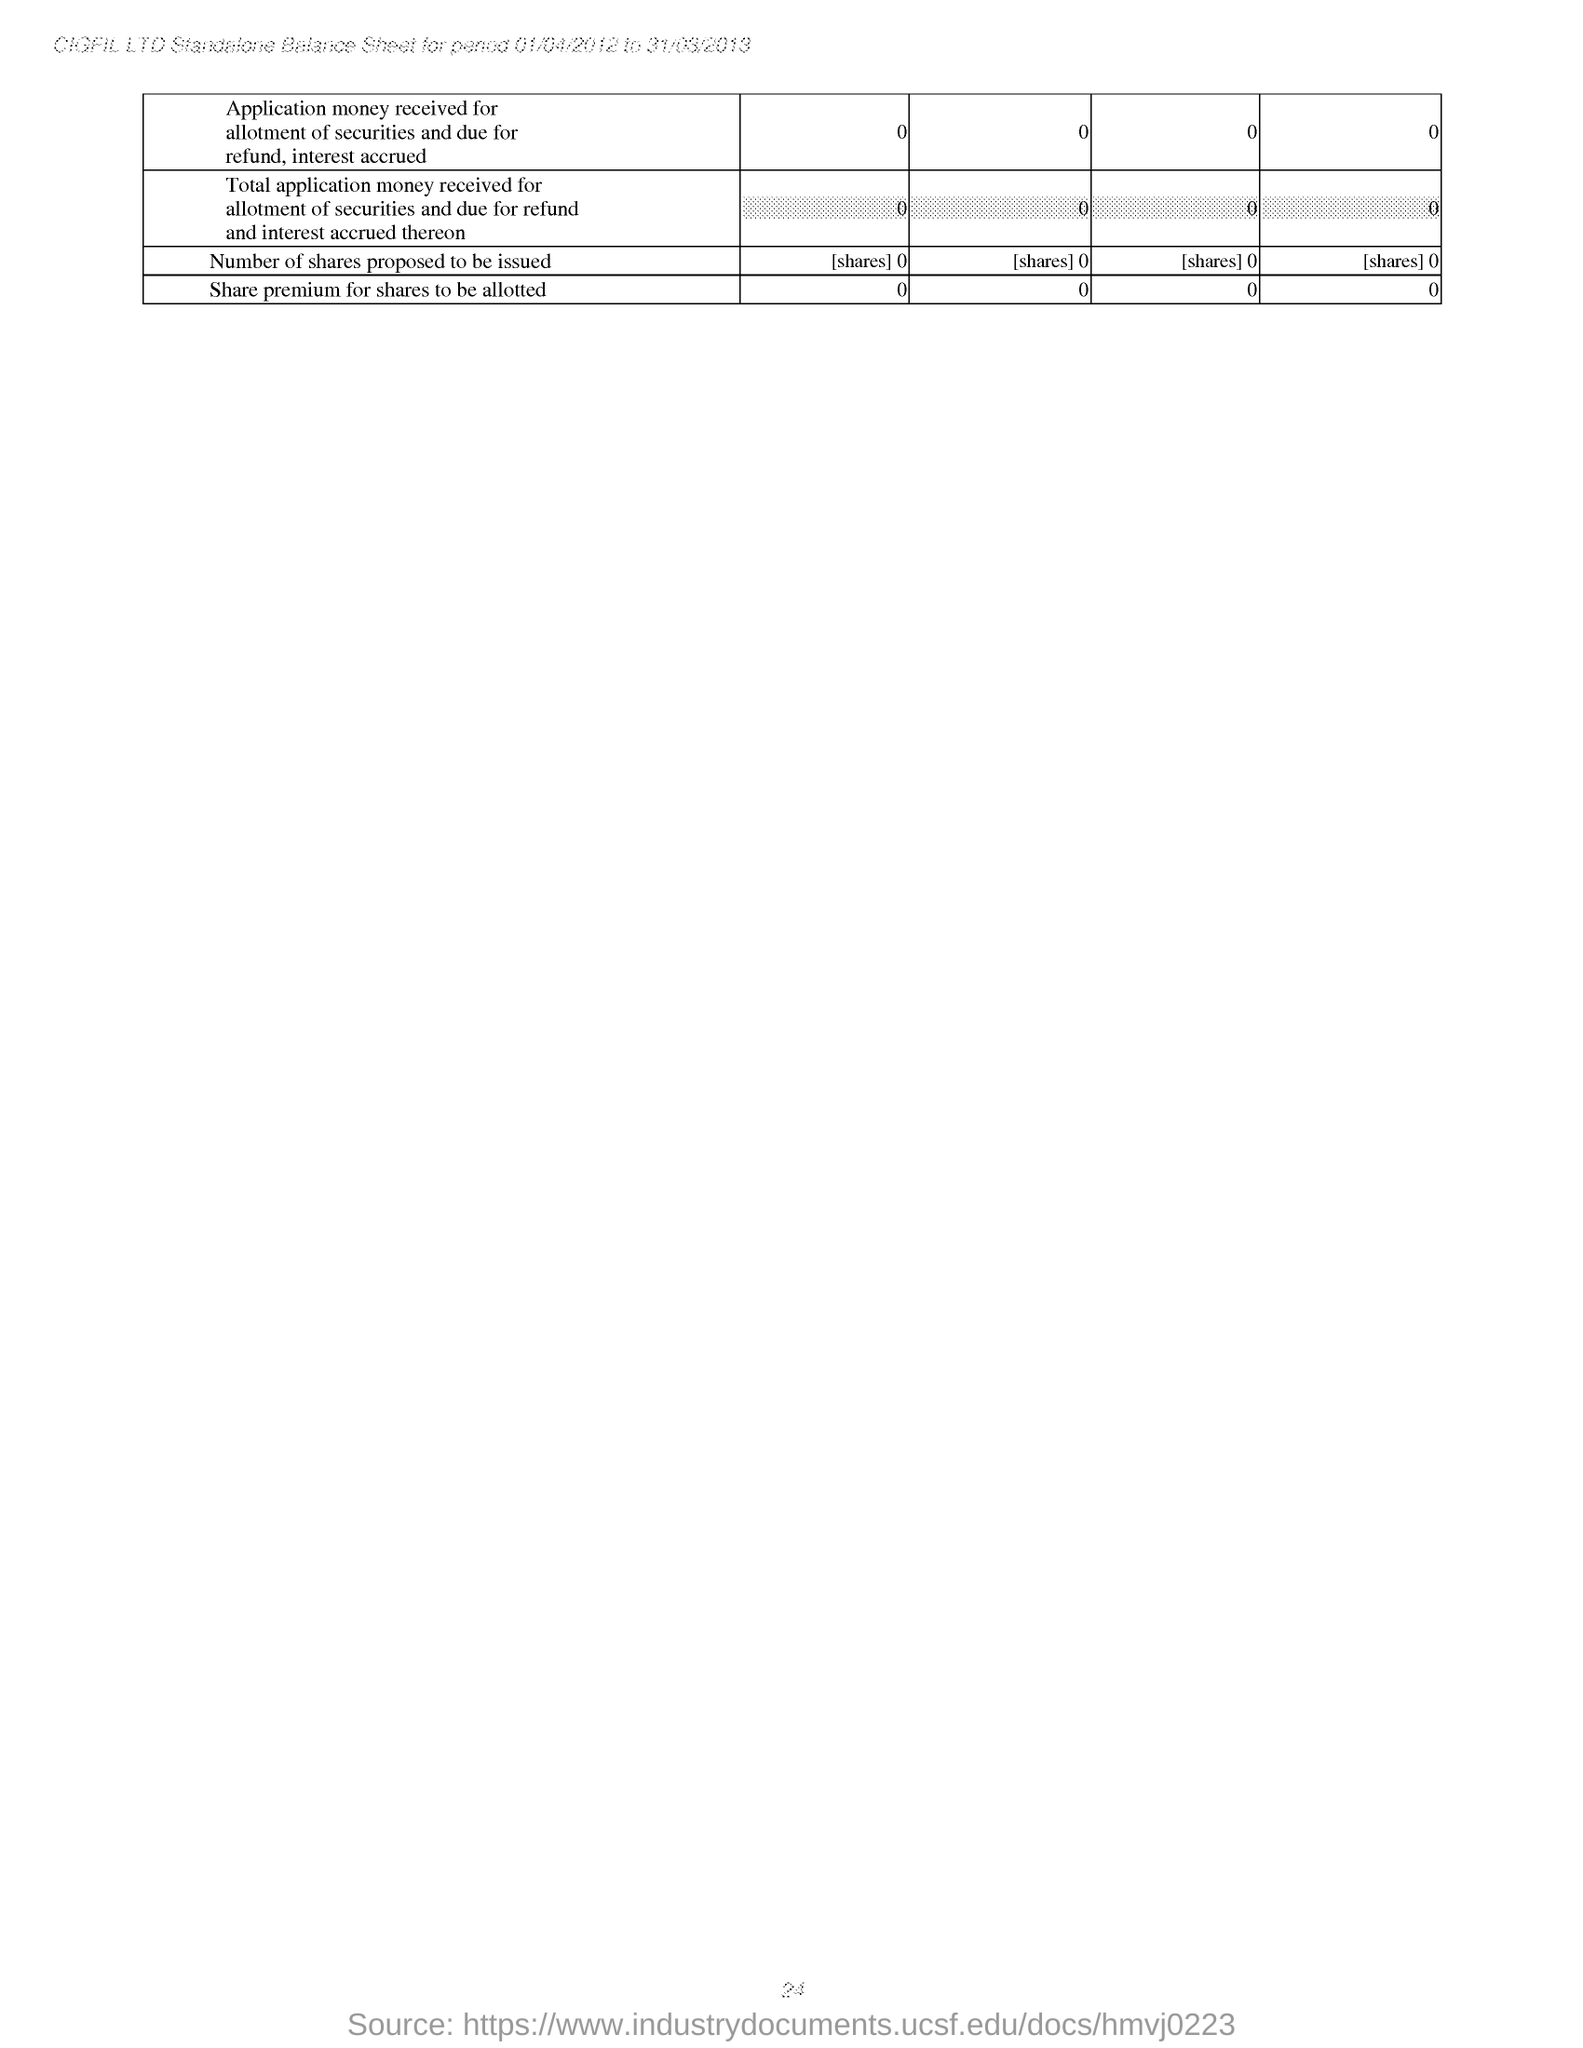Which period's Standalone Balance sheet is mentioned in the header of the document?
Keep it short and to the point. 01/04/2012 to 31/03/2013. Which company name is mentioned in the header ?
Provide a short and direct response. CIGFIL LTD. 